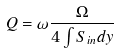<formula> <loc_0><loc_0><loc_500><loc_500>Q = \omega \frac { \Omega } { 4 \int S _ { i n } d y }</formula> 